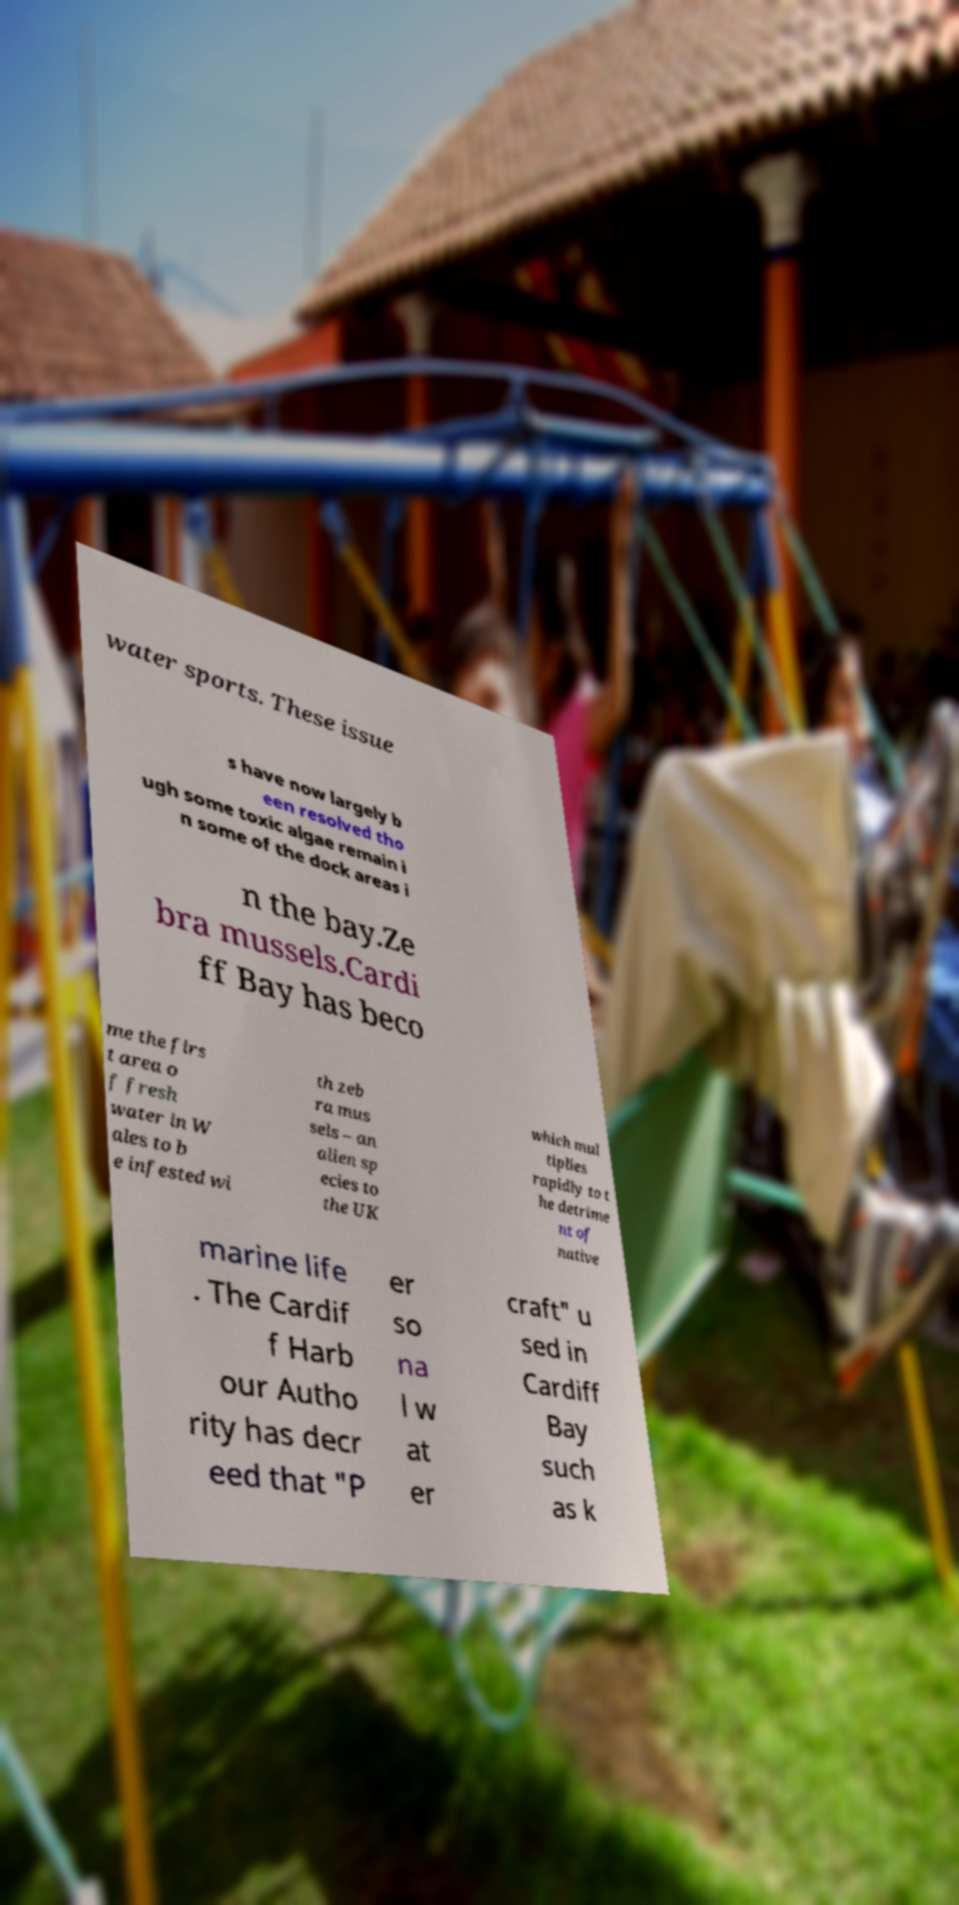There's text embedded in this image that I need extracted. Can you transcribe it verbatim? water sports. These issue s have now largely b een resolved tho ugh some toxic algae remain i n some of the dock areas i n the bay.Ze bra mussels.Cardi ff Bay has beco me the firs t area o f fresh water in W ales to b e infested wi th zeb ra mus sels – an alien sp ecies to the UK which mul tiplies rapidly to t he detrime nt of native marine life . The Cardif f Harb our Autho rity has decr eed that "P er so na l w at er craft" u sed in Cardiff Bay such as k 